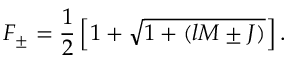Convert formula to latex. <formula><loc_0><loc_0><loc_500><loc_500>F _ { \pm } = \frac { 1 } { 2 } \left [ 1 + \sqrt { 1 + ( l M \pm J ) } \right ] .</formula> 